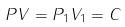Convert formula to latex. <formula><loc_0><loc_0><loc_500><loc_500>P V = P _ { 1 } V _ { 1 } = C</formula> 